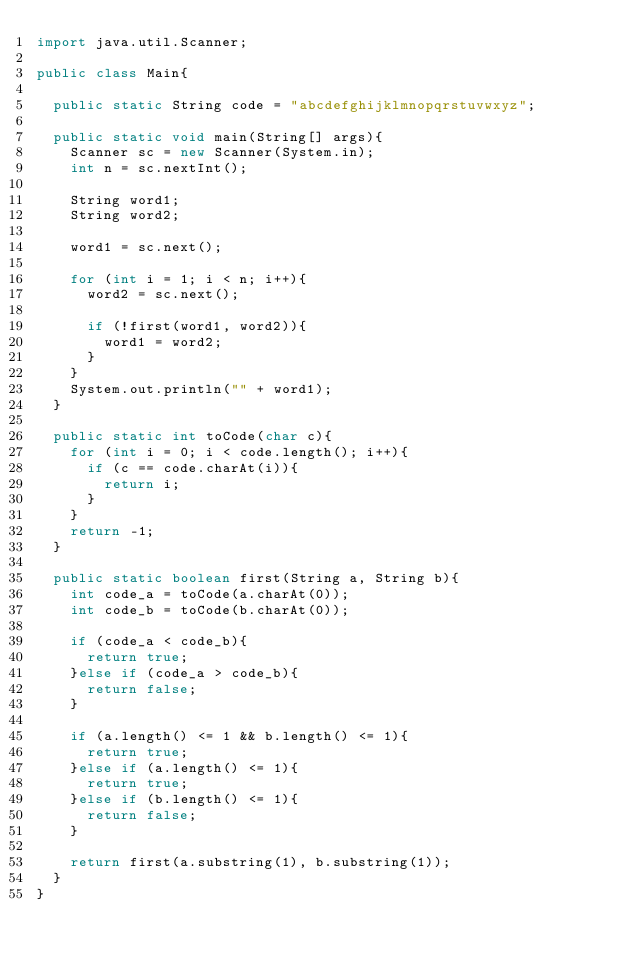Convert code to text. <code><loc_0><loc_0><loc_500><loc_500><_Java_>import java.util.Scanner;

public class Main{

	public static String code = "abcdefghijklmnopqrstuvwxyz";

	public static void main(String[] args){
		Scanner sc = new Scanner(System.in);
		int n = sc.nextInt();

		String word1;
		String word2;

		word1 = sc.next();

		for (int i = 1; i < n; i++){
			word2 = sc.next();

			if (!first(word1, word2)){
				word1 = word2;
			}
		}
		System.out.println("" + word1);
	}

	public static int toCode(char c){
		for (int i = 0; i < code.length(); i++){
			if (c == code.charAt(i)){
				return i;
			}
		}
		return -1;
	}

	public static boolean first(String a, String b){
		int code_a = toCode(a.charAt(0));
		int code_b = toCode(b.charAt(0));

		if (code_a < code_b){
			return true;
		}else if (code_a > code_b){
			return false;
		}

		if (a.length() <= 1 && b.length() <= 1){
			return true;
		}else if (a.length() <= 1){
			return true;
		}else if (b.length() <= 1){
			return false;
		}

		return first(a.substring(1), b.substring(1));
	}
}</code> 